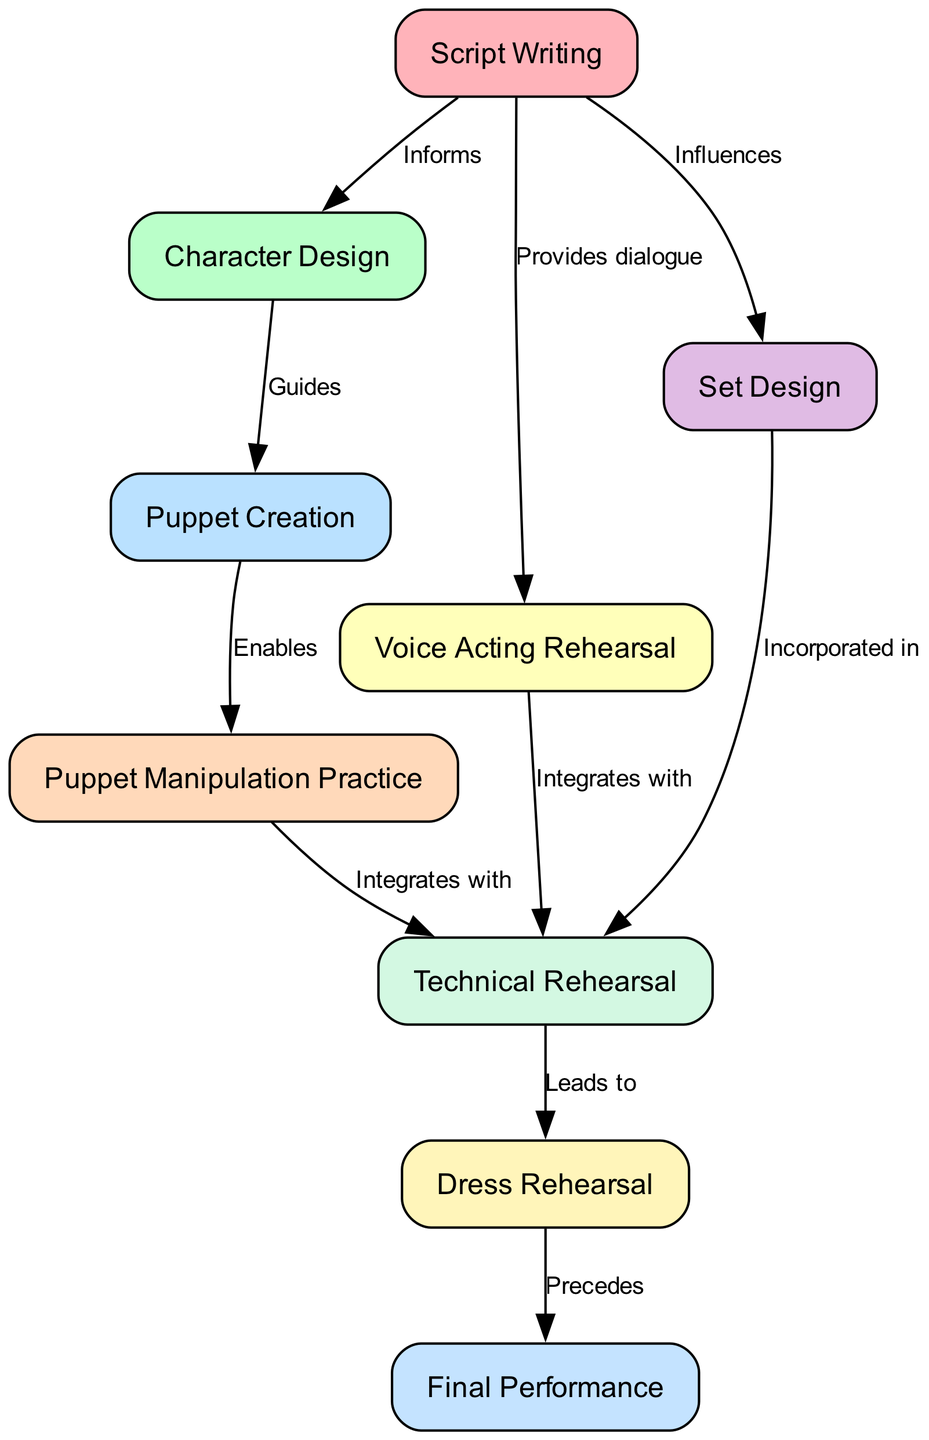What is the first node in the production process? The first node in the production process, as indicated in the diagram, is "Script Writing." It is the starting point where everything begins.
Answer: Script Writing How many total nodes are present in the diagram? By counting the nodes listed in the diagram, there are a total of nine distinct nodes representing various steps of the puppet show production process.
Answer: 9 What type of relationship connects "Script Writing" and "Character Design"? The relationship between "Script Writing" and "Character Design" is labeled "Informs," which means that the information or narrative presented in the script influences the design of the characters.
Answer: Informs Which node follows "Technical Rehearsal"? "Dress Rehearsal" is the node that directly follows "Technical Rehearsal" in the flowchart, indicating the progression from technical preparations to a full practice performance.
Answer: Dress Rehearsal What is the last step in the puppet show production process? The final step in the production process, as shown in the diagram, is "Final Performance," marking the culmination of all previous efforts and rehearsals into the completed show.
Answer: Final Performance What guides the "Puppet Creation" process? The "Character Design" guides the "Puppet Creation" process, implying that the visual and conceptual design of the characters shapes how the puppets are actually created.
Answer: Guides Which two nodes integrate with "Technical Rehearsal"? "Voice Acting Rehearsal" and "Puppet Manipulation Practice" both integrate with "Technical Rehearsal," signifying they are combined or adjusted within the technical aspects of the production.
Answer: Voice Acting Rehearsal, Puppet Manipulation Practice What does "Dress Rehearsal" precede? "Final Performance" is what "Dress Rehearsal" precedes, indicating that the last practice run takes place just before the actual presentation of the show.
Answer: Final Performance How does "Script Writing" influence "Set Design"? "Script Writing" influences "Set Design" by providing thematic and situational context that determines how the set is constructed and visually represented in conjunction with the story.
Answer: Influences 